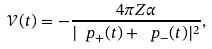Convert formula to latex. <formula><loc_0><loc_0><loc_500><loc_500>\mathcal { V } ( t ) = - \frac { 4 \pi Z \alpha } { | \ p _ { + } ( t ) + \ p _ { - } ( t ) | ^ { 2 } } ,</formula> 